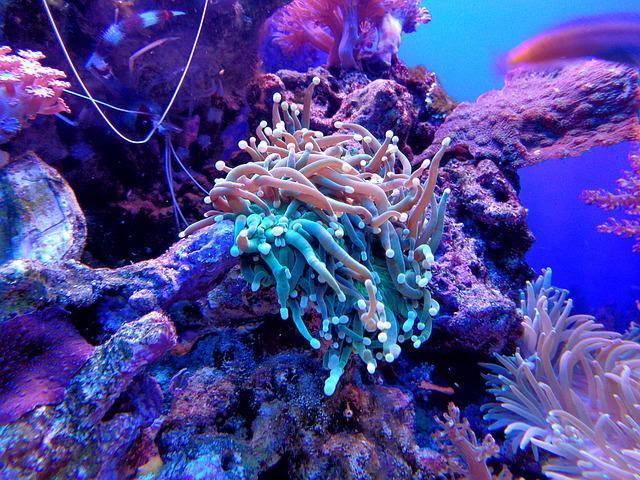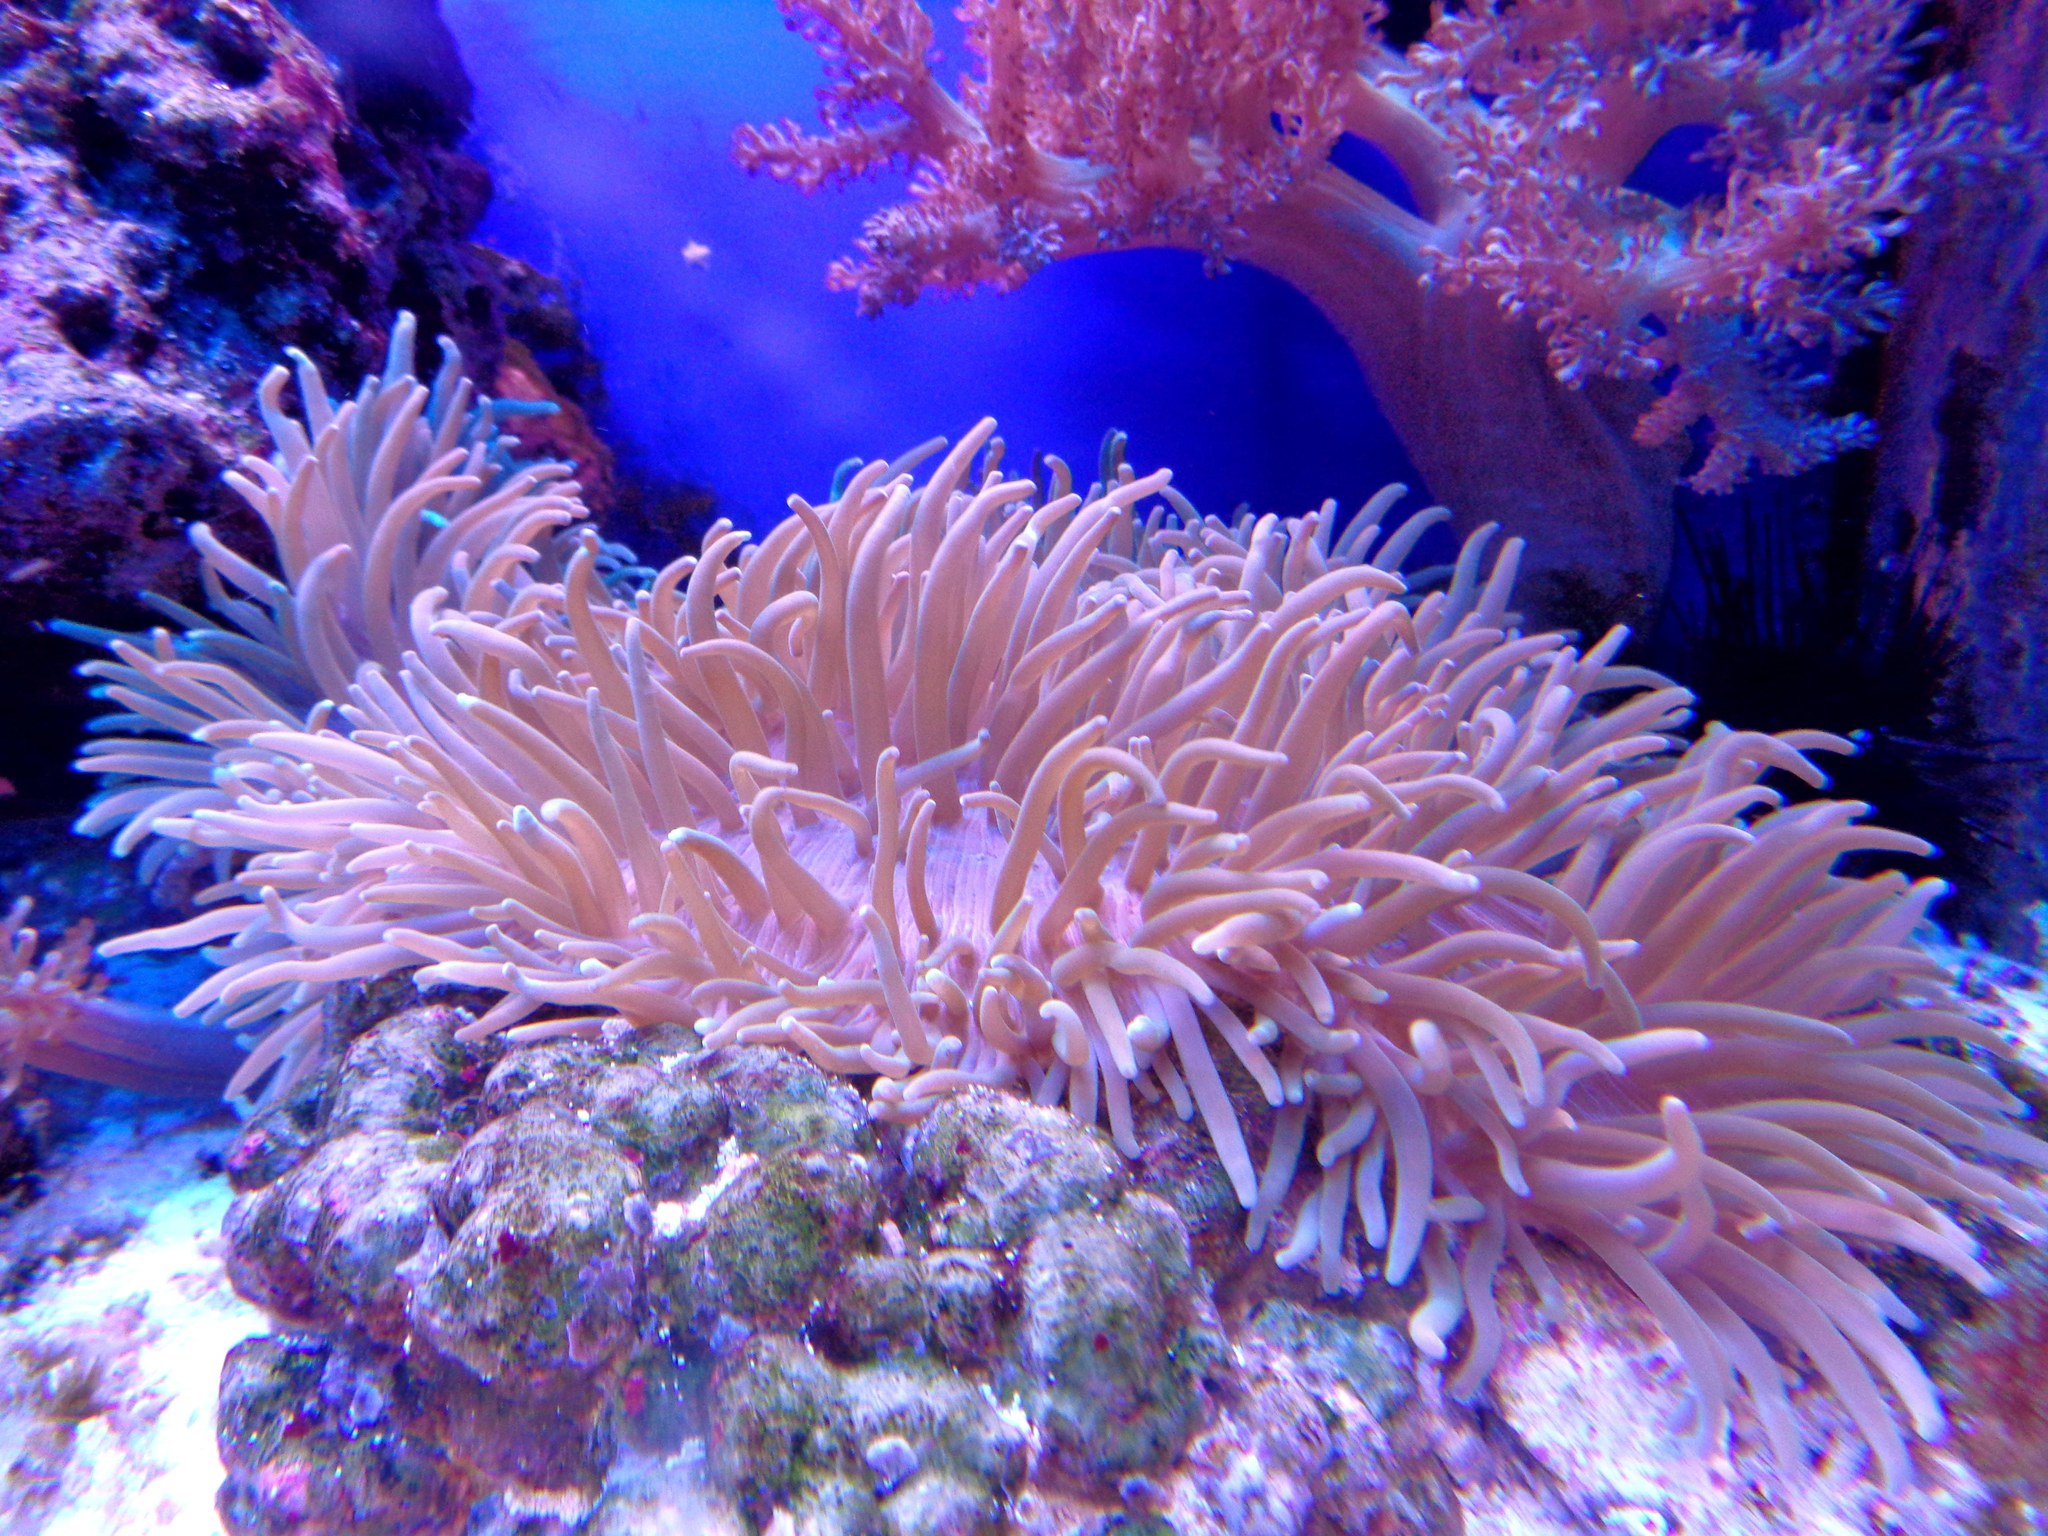The first image is the image on the left, the second image is the image on the right. Analyze the images presented: Is the assertion "At least one sea anemone is pedominantly pink." valid? Answer yes or no. Yes. 